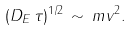<formula> <loc_0><loc_0><loc_500><loc_500>( D _ { E } \, \tau ) ^ { 1 / 2 } \, \sim \, m v ^ { 2 } .</formula> 